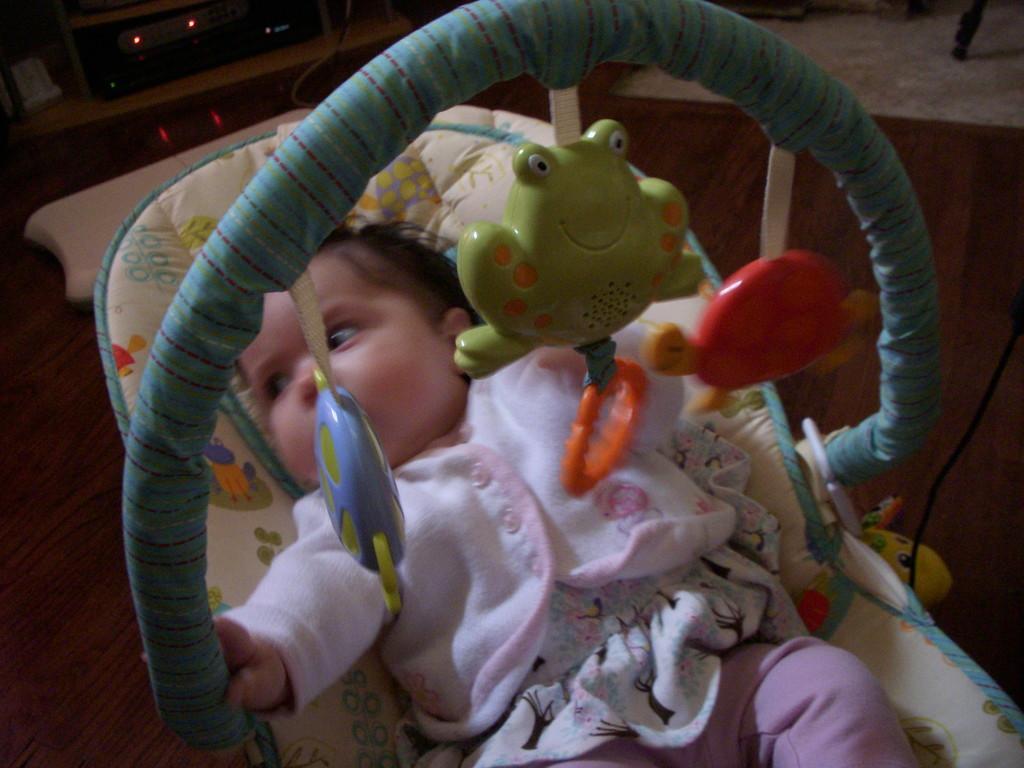Could you give a brief overview of what you see in this image? In this image we can see a baby cot, there a baby is lying, at above there are toys. 